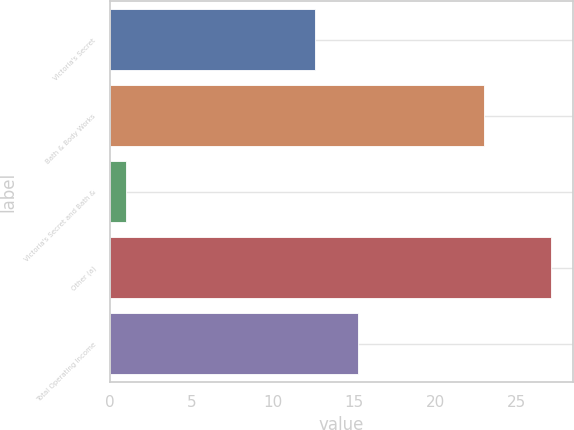<chart> <loc_0><loc_0><loc_500><loc_500><bar_chart><fcel>Victoria's Secret<fcel>Bath & Body Works<fcel>Victoria's Secret and Bath &<fcel>Other (a)<fcel>Total Operating Income<nl><fcel>12.6<fcel>23<fcel>1<fcel>27.1<fcel>15.21<nl></chart> 